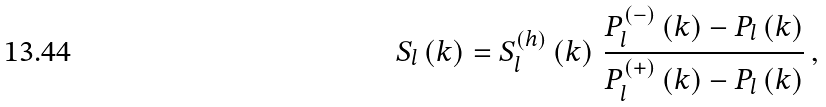<formula> <loc_0><loc_0><loc_500><loc_500>S _ { l } \left ( k \right ) = S _ { l } ^ { ( h ) } \left ( k \right ) \, \frac { P _ { l } ^ { \left ( - \right ) } \left ( k \right ) - P _ { l } \left ( k \right ) } { P _ { l } ^ { \left ( + \right ) } \left ( k \right ) - P _ { l } \left ( k \right ) } \, ,</formula> 